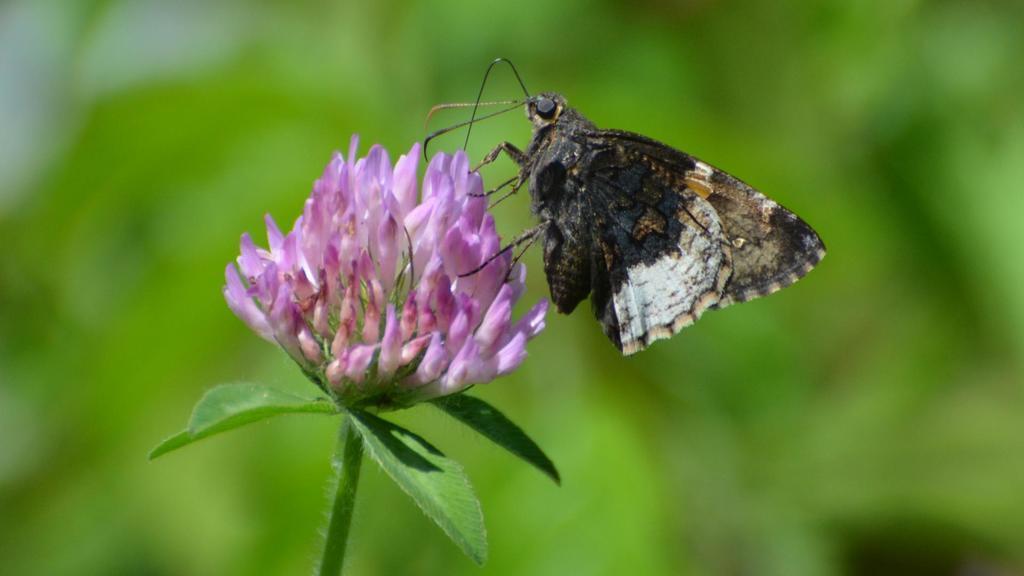Describe this image in one or two sentences. In this picture I can see a butterfly on the flower and I can see blurry background. 